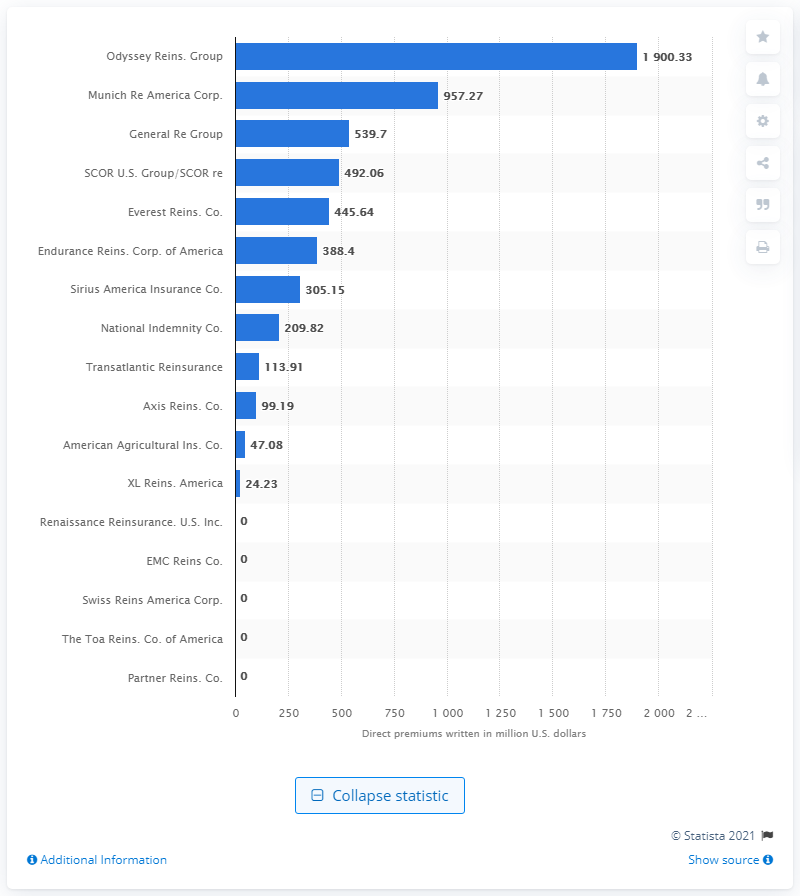Outline some significant characteristics in this image. In 2020, the direct premiums written by Odyssey Group amounted to $1,900.33 in dollars. 